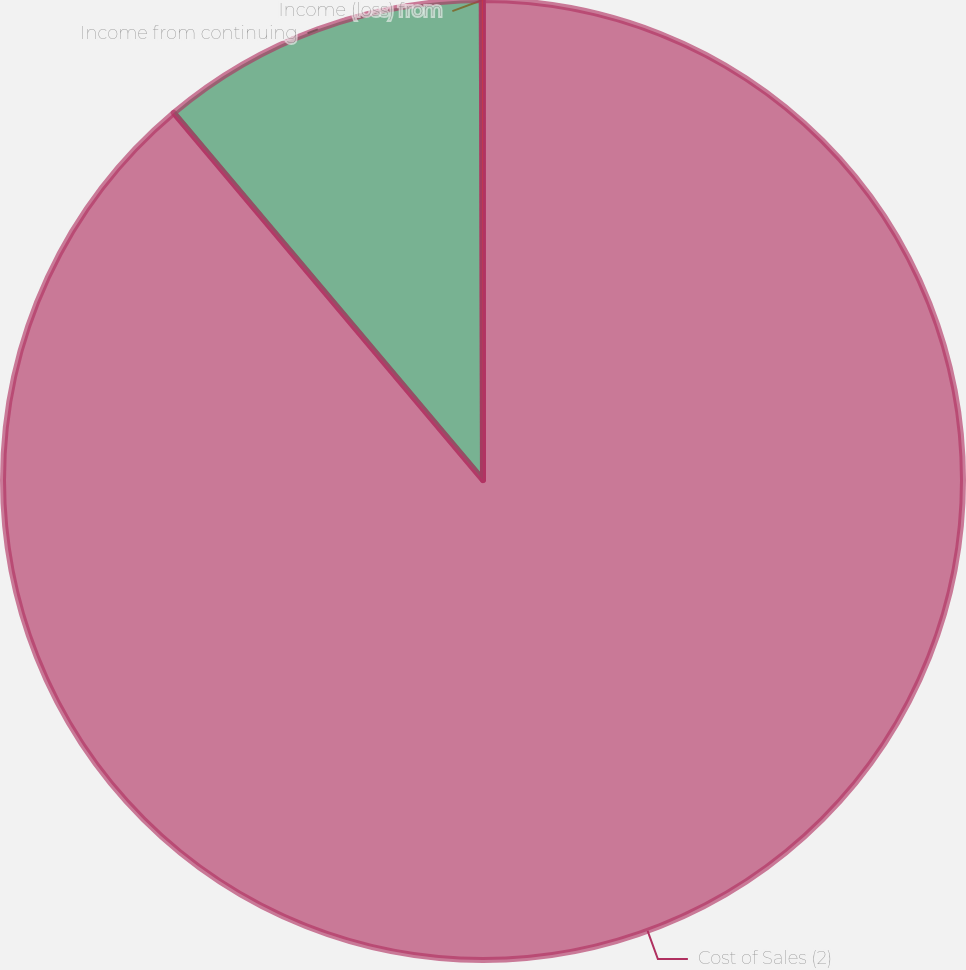Convert chart. <chart><loc_0><loc_0><loc_500><loc_500><pie_chart><fcel>Cost of Sales (2)<fcel>Income from continuing<fcel>Income (loss) from<nl><fcel>88.85%<fcel>11.1%<fcel>0.04%<nl></chart> 